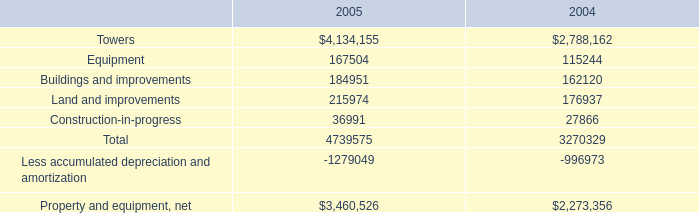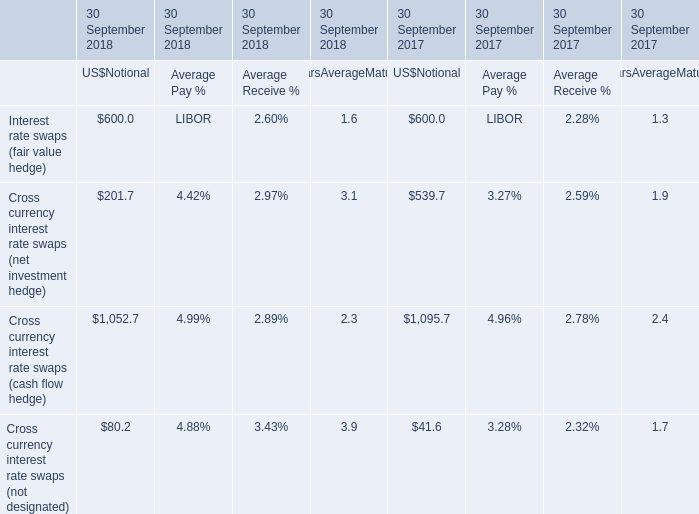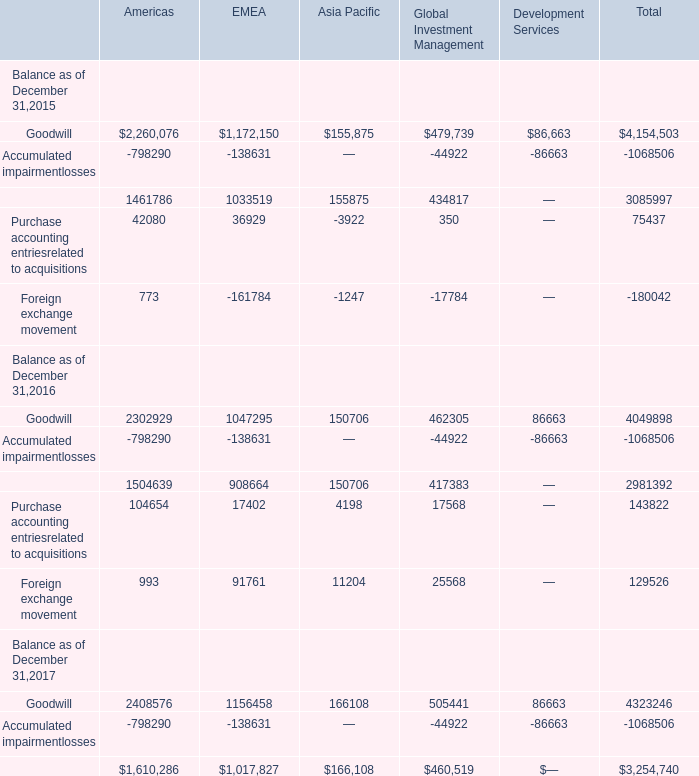what was the percentage increase in the property and equipment net from 2004 to 2005 
Computations: ((3460526 - 2273356) / 2273356)
Answer: 0.52221. 